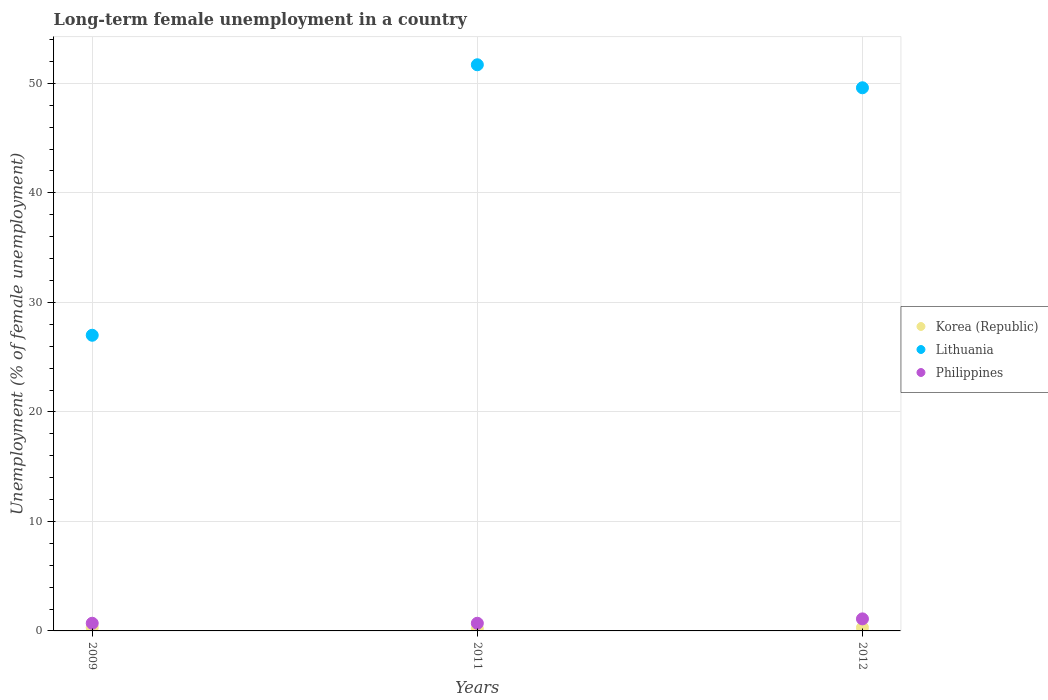How many different coloured dotlines are there?
Provide a succinct answer. 3. Across all years, what is the maximum percentage of long-term unemployed female population in Lithuania?
Give a very brief answer. 51.7. Across all years, what is the minimum percentage of long-term unemployed female population in Korea (Republic)?
Offer a terse response. 0.2. What is the total percentage of long-term unemployed female population in Lithuania in the graph?
Your response must be concise. 128.3. What is the difference between the percentage of long-term unemployed female population in Lithuania in 2009 and that in 2012?
Provide a short and direct response. -22.6. What is the difference between the percentage of long-term unemployed female population in Lithuania in 2012 and the percentage of long-term unemployed female population in Philippines in 2009?
Keep it short and to the point. 48.9. What is the average percentage of long-term unemployed female population in Philippines per year?
Your response must be concise. 0.83. In the year 2011, what is the difference between the percentage of long-term unemployed female population in Korea (Republic) and percentage of long-term unemployed female population in Philippines?
Your answer should be compact. -0.5. In how many years, is the percentage of long-term unemployed female population in Korea (Republic) greater than 44 %?
Keep it short and to the point. 0. What is the ratio of the percentage of long-term unemployed female population in Philippines in 2009 to that in 2011?
Offer a very short reply. 1. What is the difference between the highest and the second highest percentage of long-term unemployed female population in Philippines?
Provide a short and direct response. 0.4. What is the difference between the highest and the lowest percentage of long-term unemployed female population in Lithuania?
Give a very brief answer. 24.7. Is it the case that in every year, the sum of the percentage of long-term unemployed female population in Lithuania and percentage of long-term unemployed female population in Philippines  is greater than the percentage of long-term unemployed female population in Korea (Republic)?
Provide a short and direct response. Yes. Does the percentage of long-term unemployed female population in Lithuania monotonically increase over the years?
Provide a short and direct response. No. Is the percentage of long-term unemployed female population in Philippines strictly greater than the percentage of long-term unemployed female population in Lithuania over the years?
Give a very brief answer. No. How many dotlines are there?
Your answer should be compact. 3. How many years are there in the graph?
Provide a short and direct response. 3. What is the difference between two consecutive major ticks on the Y-axis?
Your response must be concise. 10. Are the values on the major ticks of Y-axis written in scientific E-notation?
Keep it short and to the point. No. Does the graph contain any zero values?
Keep it short and to the point. No. Where does the legend appear in the graph?
Your answer should be very brief. Center right. How are the legend labels stacked?
Give a very brief answer. Vertical. What is the title of the graph?
Give a very brief answer. Long-term female unemployment in a country. What is the label or title of the Y-axis?
Keep it short and to the point. Unemployment (% of female unemployment). What is the Unemployment (% of female unemployment) of Korea (Republic) in 2009?
Offer a terse response. 0.3. What is the Unemployment (% of female unemployment) of Lithuania in 2009?
Give a very brief answer. 27. What is the Unemployment (% of female unemployment) in Philippines in 2009?
Provide a succinct answer. 0.7. What is the Unemployment (% of female unemployment) in Korea (Republic) in 2011?
Make the answer very short. 0.2. What is the Unemployment (% of female unemployment) in Lithuania in 2011?
Keep it short and to the point. 51.7. What is the Unemployment (% of female unemployment) of Philippines in 2011?
Ensure brevity in your answer.  0.7. What is the Unemployment (% of female unemployment) of Korea (Republic) in 2012?
Make the answer very short. 0.3. What is the Unemployment (% of female unemployment) in Lithuania in 2012?
Offer a terse response. 49.6. What is the Unemployment (% of female unemployment) of Philippines in 2012?
Make the answer very short. 1.1. Across all years, what is the maximum Unemployment (% of female unemployment) in Korea (Republic)?
Ensure brevity in your answer.  0.3. Across all years, what is the maximum Unemployment (% of female unemployment) in Lithuania?
Offer a terse response. 51.7. Across all years, what is the maximum Unemployment (% of female unemployment) of Philippines?
Your answer should be very brief. 1.1. Across all years, what is the minimum Unemployment (% of female unemployment) in Korea (Republic)?
Your answer should be very brief. 0.2. Across all years, what is the minimum Unemployment (% of female unemployment) of Philippines?
Offer a terse response. 0.7. What is the total Unemployment (% of female unemployment) of Lithuania in the graph?
Provide a succinct answer. 128.3. What is the difference between the Unemployment (% of female unemployment) of Korea (Republic) in 2009 and that in 2011?
Keep it short and to the point. 0.1. What is the difference between the Unemployment (% of female unemployment) in Lithuania in 2009 and that in 2011?
Your response must be concise. -24.7. What is the difference between the Unemployment (% of female unemployment) of Korea (Republic) in 2009 and that in 2012?
Offer a very short reply. 0. What is the difference between the Unemployment (% of female unemployment) in Lithuania in 2009 and that in 2012?
Provide a succinct answer. -22.6. What is the difference between the Unemployment (% of female unemployment) in Korea (Republic) in 2011 and that in 2012?
Provide a succinct answer. -0.1. What is the difference between the Unemployment (% of female unemployment) of Lithuania in 2011 and that in 2012?
Make the answer very short. 2.1. What is the difference between the Unemployment (% of female unemployment) of Philippines in 2011 and that in 2012?
Make the answer very short. -0.4. What is the difference between the Unemployment (% of female unemployment) of Korea (Republic) in 2009 and the Unemployment (% of female unemployment) of Lithuania in 2011?
Your answer should be compact. -51.4. What is the difference between the Unemployment (% of female unemployment) of Korea (Republic) in 2009 and the Unemployment (% of female unemployment) of Philippines in 2011?
Your answer should be compact. -0.4. What is the difference between the Unemployment (% of female unemployment) of Lithuania in 2009 and the Unemployment (% of female unemployment) of Philippines in 2011?
Provide a succinct answer. 26.3. What is the difference between the Unemployment (% of female unemployment) of Korea (Republic) in 2009 and the Unemployment (% of female unemployment) of Lithuania in 2012?
Give a very brief answer. -49.3. What is the difference between the Unemployment (% of female unemployment) in Lithuania in 2009 and the Unemployment (% of female unemployment) in Philippines in 2012?
Give a very brief answer. 25.9. What is the difference between the Unemployment (% of female unemployment) of Korea (Republic) in 2011 and the Unemployment (% of female unemployment) of Lithuania in 2012?
Provide a short and direct response. -49.4. What is the difference between the Unemployment (% of female unemployment) of Korea (Republic) in 2011 and the Unemployment (% of female unemployment) of Philippines in 2012?
Give a very brief answer. -0.9. What is the difference between the Unemployment (% of female unemployment) of Lithuania in 2011 and the Unemployment (% of female unemployment) of Philippines in 2012?
Your response must be concise. 50.6. What is the average Unemployment (% of female unemployment) of Korea (Republic) per year?
Your answer should be compact. 0.27. What is the average Unemployment (% of female unemployment) in Lithuania per year?
Your answer should be very brief. 42.77. In the year 2009, what is the difference between the Unemployment (% of female unemployment) in Korea (Republic) and Unemployment (% of female unemployment) in Lithuania?
Your response must be concise. -26.7. In the year 2009, what is the difference between the Unemployment (% of female unemployment) of Korea (Republic) and Unemployment (% of female unemployment) of Philippines?
Provide a succinct answer. -0.4. In the year 2009, what is the difference between the Unemployment (% of female unemployment) in Lithuania and Unemployment (% of female unemployment) in Philippines?
Keep it short and to the point. 26.3. In the year 2011, what is the difference between the Unemployment (% of female unemployment) of Korea (Republic) and Unemployment (% of female unemployment) of Lithuania?
Your answer should be very brief. -51.5. In the year 2011, what is the difference between the Unemployment (% of female unemployment) in Korea (Republic) and Unemployment (% of female unemployment) in Philippines?
Your answer should be compact. -0.5. In the year 2012, what is the difference between the Unemployment (% of female unemployment) in Korea (Republic) and Unemployment (% of female unemployment) in Lithuania?
Provide a short and direct response. -49.3. In the year 2012, what is the difference between the Unemployment (% of female unemployment) of Lithuania and Unemployment (% of female unemployment) of Philippines?
Offer a terse response. 48.5. What is the ratio of the Unemployment (% of female unemployment) in Korea (Republic) in 2009 to that in 2011?
Keep it short and to the point. 1.5. What is the ratio of the Unemployment (% of female unemployment) in Lithuania in 2009 to that in 2011?
Provide a short and direct response. 0.52. What is the ratio of the Unemployment (% of female unemployment) of Philippines in 2009 to that in 2011?
Offer a very short reply. 1. What is the ratio of the Unemployment (% of female unemployment) in Korea (Republic) in 2009 to that in 2012?
Provide a short and direct response. 1. What is the ratio of the Unemployment (% of female unemployment) of Lithuania in 2009 to that in 2012?
Keep it short and to the point. 0.54. What is the ratio of the Unemployment (% of female unemployment) in Philippines in 2009 to that in 2012?
Ensure brevity in your answer.  0.64. What is the ratio of the Unemployment (% of female unemployment) of Korea (Republic) in 2011 to that in 2012?
Your answer should be compact. 0.67. What is the ratio of the Unemployment (% of female unemployment) in Lithuania in 2011 to that in 2012?
Keep it short and to the point. 1.04. What is the ratio of the Unemployment (% of female unemployment) of Philippines in 2011 to that in 2012?
Your answer should be compact. 0.64. What is the difference between the highest and the second highest Unemployment (% of female unemployment) in Korea (Republic)?
Give a very brief answer. 0. What is the difference between the highest and the second highest Unemployment (% of female unemployment) of Philippines?
Offer a terse response. 0.4. What is the difference between the highest and the lowest Unemployment (% of female unemployment) in Lithuania?
Offer a very short reply. 24.7. What is the difference between the highest and the lowest Unemployment (% of female unemployment) of Philippines?
Your answer should be very brief. 0.4. 